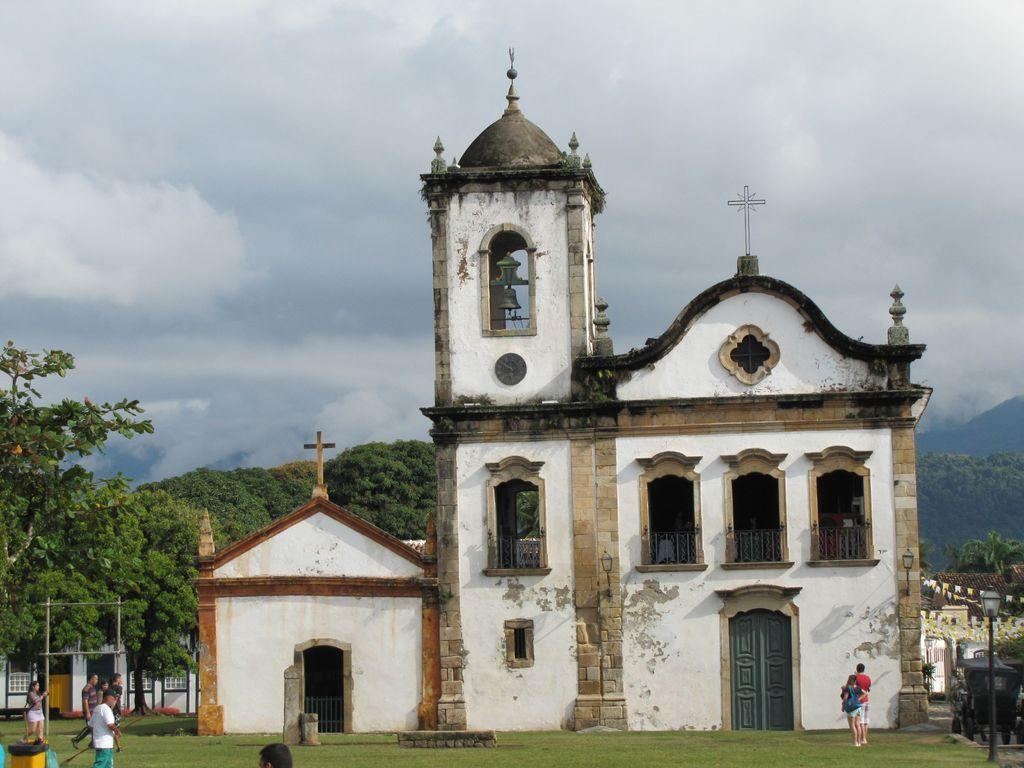What type of building is in the image? There is a church in the image. What features can be seen on the church? The church has grills, doors, and lights. What is happening in the foreground of the image? There are people walking on the grass in the image. What type of vegetation is present in the image? There are trees in the image. What else can be seen in the image? There is a pole in the image. What can be seen in the background of the image? The sky is visible in the background of the image. What type of bottle is being used to cause trouble in the argument at the church? There is no bottle or argument present in the image. The image only shows a church with people walking on the grass, trees, a pole, and a visible sky in the background. 